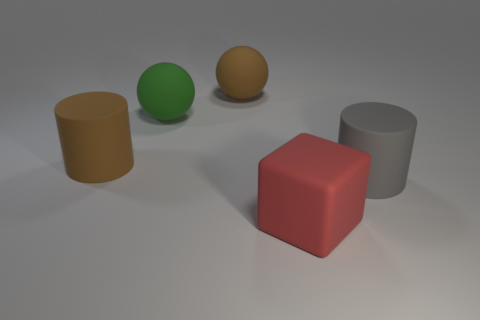Is there anything else that has the same shape as the large red rubber object?
Ensure brevity in your answer.  No. There is a large gray object that is right of the matte cylinder that is on the left side of the thing right of the large red object; what is its shape?
Ensure brevity in your answer.  Cylinder. There is a red thing that is made of the same material as the brown cylinder; what is its shape?
Provide a short and direct response. Cube. Is the size of the brown matte sphere the same as the gray rubber cylinder?
Offer a terse response. Yes. What number of things are big brown matte objects in front of the green sphere or big cylinders behind the big gray rubber cylinder?
Your answer should be compact. 1. There is a large matte sphere in front of the big brown thing behind the large green object; how many large red matte objects are in front of it?
Your answer should be compact. 1. What number of other brown matte balls are the same size as the brown sphere?
Make the answer very short. 0. What number of things are large brown rubber cubes or large red rubber blocks?
Offer a very short reply. 1. What shape is the green object that is the same size as the gray rubber thing?
Your answer should be very brief. Sphere. Are there any brown matte things of the same shape as the gray matte object?
Give a very brief answer. Yes. 